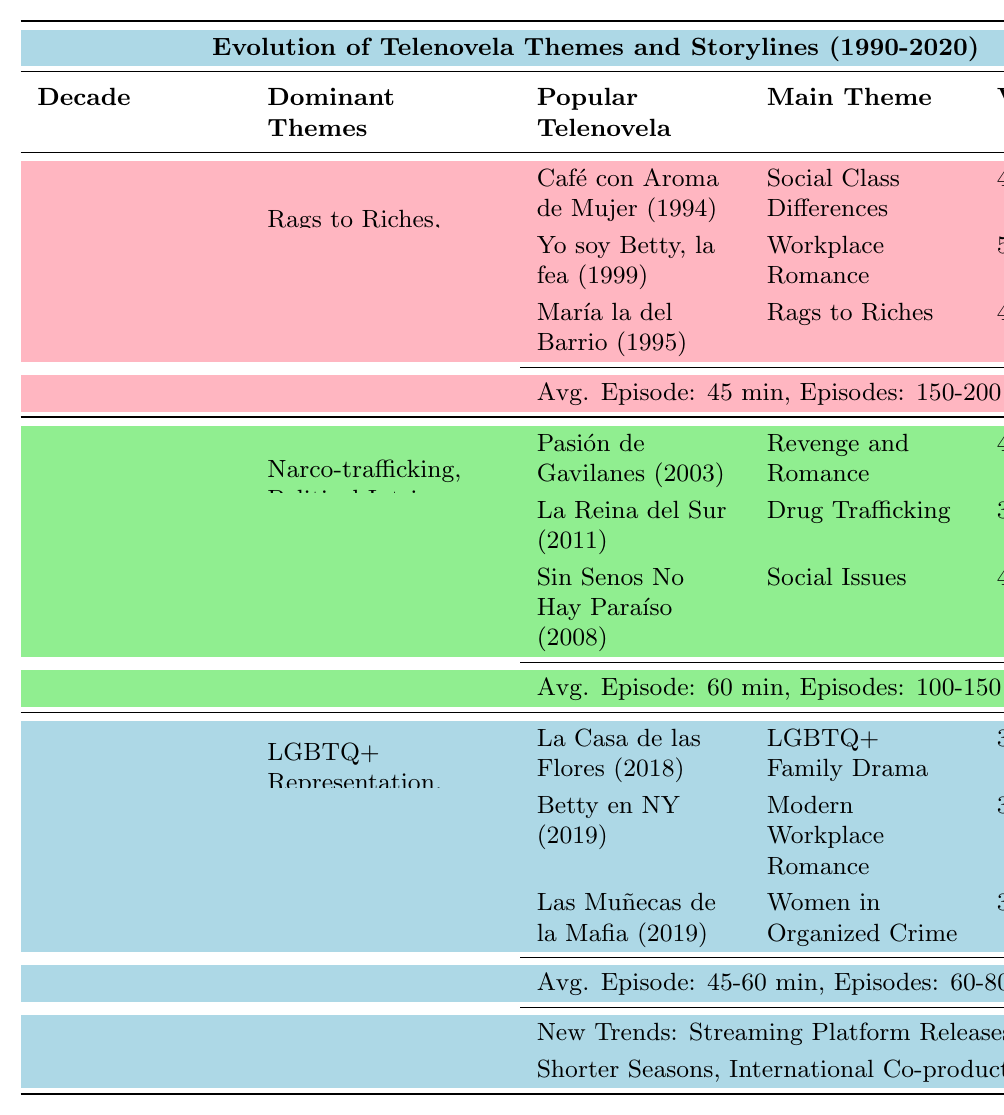What were the dominant themes of telenovelas in the 1990s? The table lists the dominant themes for the 1990s as "Rags to Riches," "Forbidden Love," and "Family Secrets."
Answer: Rags to Riches, Forbidden Love, Family Secrets Which telenovela had the highest viewership rating in the 1990s? The table shows that "Yo soy Betty, la fea (1999)" had a viewership rating of 52%, which is the highest among the listed telenovelas in the 1990s.
Answer: Yo soy Betty, la fea (1999) Was "Pasión de Gavilanes" more popular than "La Reina del Sur"? "Pasión de Gavilanes" had a viewership rating of 43%, while "La Reina del Sur" had a rating of 38%. Therefore, "Pasión de Gavilanes" was more popular.
Answer: Yes What is the average episode length of telenovelas in the 2000s? The average episode length for telenovelas in the 2000s is 60 minutes, as listed in the table.
Answer: 60 minutes How many episodes did the average telenovela in the 2010s-2020 have? The table states that the typical number of episodes for telenovelas in the 2010s-2020 is "60-80." Since it's a range, it indicates a range of typical episodes.
Answer: 60-80 Which decade saw the introduction of LGBTQ+ representation as a dominant theme? According to the table, LGBTQ+ representation was a dominant theme in the 2010s-2020 period.
Answer: 2010s-2020 Based on viewership ratings, which telenovela from the 2000s is considered the least popular? "La Reina del Sur" with a viewership rating of 38% is the least popular among the listed telenovelas in the 2000s.
Answer: La Reina del Sur What is the average viewership rating for telenovelas in the 2010s-2020 compared to the 2000s? The average viewership ratings from the table are 35% in the 2010s-2020 and 40% (about) in the 2000s (43% + 38% + 41% = 122%, then 122% / 3 ≈ 40.67%). The 2010s-2020 is lower.
Answer: Lower How did the themes of telenovelas change from the 1990s to the 2000s? The dominant themes shifted from personal and family-oriented ones like "Rags to Riches," "Forbidden Love," and "Family Secrets" in the 1990s to more societal issues like "Narco-trafficking," "Political Intrigue," and "Historical Dramas" in the 2000s.
Answer: More societal issues What new trends are noted for telenovelas in the 2010s-2020? The new trends listed are "Streaming Platform Releases," "Shorter Seasons," and "International Co-productions."
Answer: Streaming Platform Releases, Shorter Seasons, International Co-productions 